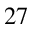Convert formula to latex. <formula><loc_0><loc_0><loc_500><loc_500>^ { 2 7 }</formula> 